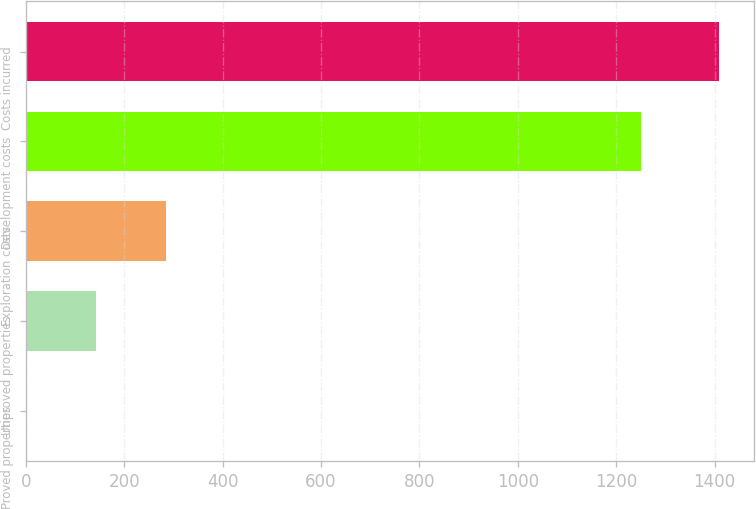Convert chart to OTSL. <chart><loc_0><loc_0><loc_500><loc_500><bar_chart><fcel>Proved properties<fcel>Unproved properties<fcel>Exploration costs<fcel>Development costs<fcel>Costs incurred<nl><fcel>3<fcel>143.6<fcel>284.2<fcel>1251<fcel>1409<nl></chart> 